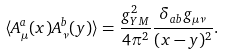Convert formula to latex. <formula><loc_0><loc_0><loc_500><loc_500>\langle A ^ { a } _ { \mu } ( x ) A ^ { b } _ { \nu } ( y ) \rangle = \frac { g _ { Y M } ^ { 2 } } { 4 \pi ^ { 2 } } \frac { \delta _ { a b } g _ { \mu \nu } } { ( x - y ) ^ { 2 } } .</formula> 